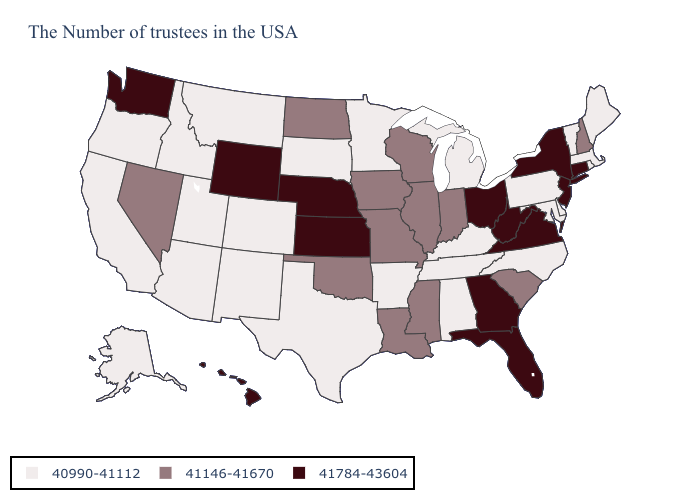What is the value of Washington?
Quick response, please. 41784-43604. Among the states that border Ohio , which have the highest value?
Answer briefly. West Virginia. Which states have the lowest value in the USA?
Give a very brief answer. Maine, Massachusetts, Rhode Island, Vermont, Delaware, Maryland, Pennsylvania, North Carolina, Michigan, Kentucky, Alabama, Tennessee, Arkansas, Minnesota, Texas, South Dakota, Colorado, New Mexico, Utah, Montana, Arizona, Idaho, California, Oregon, Alaska. Does Hawaii have the highest value in the USA?
Answer briefly. Yes. Which states have the lowest value in the South?
Concise answer only. Delaware, Maryland, North Carolina, Kentucky, Alabama, Tennessee, Arkansas, Texas. What is the lowest value in the MidWest?
Concise answer only. 40990-41112. What is the lowest value in the Northeast?
Concise answer only. 40990-41112. Which states have the highest value in the USA?
Answer briefly. Connecticut, New York, New Jersey, Virginia, West Virginia, Ohio, Florida, Georgia, Kansas, Nebraska, Wyoming, Washington, Hawaii. Among the states that border Utah , which have the highest value?
Be succinct. Wyoming. What is the value of New Jersey?
Keep it brief. 41784-43604. Which states have the highest value in the USA?
Short answer required. Connecticut, New York, New Jersey, Virginia, West Virginia, Ohio, Florida, Georgia, Kansas, Nebraska, Wyoming, Washington, Hawaii. What is the value of Idaho?
Keep it brief. 40990-41112. Does the first symbol in the legend represent the smallest category?
Write a very short answer. Yes. What is the value of Virginia?
Answer briefly. 41784-43604. What is the highest value in the USA?
Give a very brief answer. 41784-43604. 